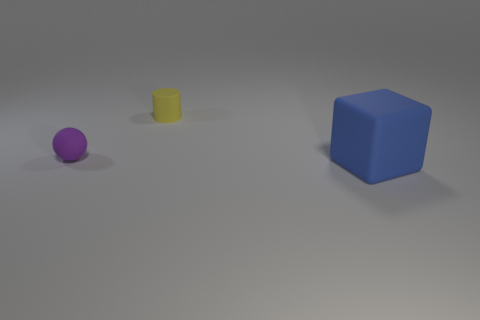How big is the object behind the small matte thing that is to the left of the small cylinder? The object behind the small matte sphere to the left of the small cylinder is a sizable blue cube, which appears to be significantly larger than both the cylinder and the sphere. 